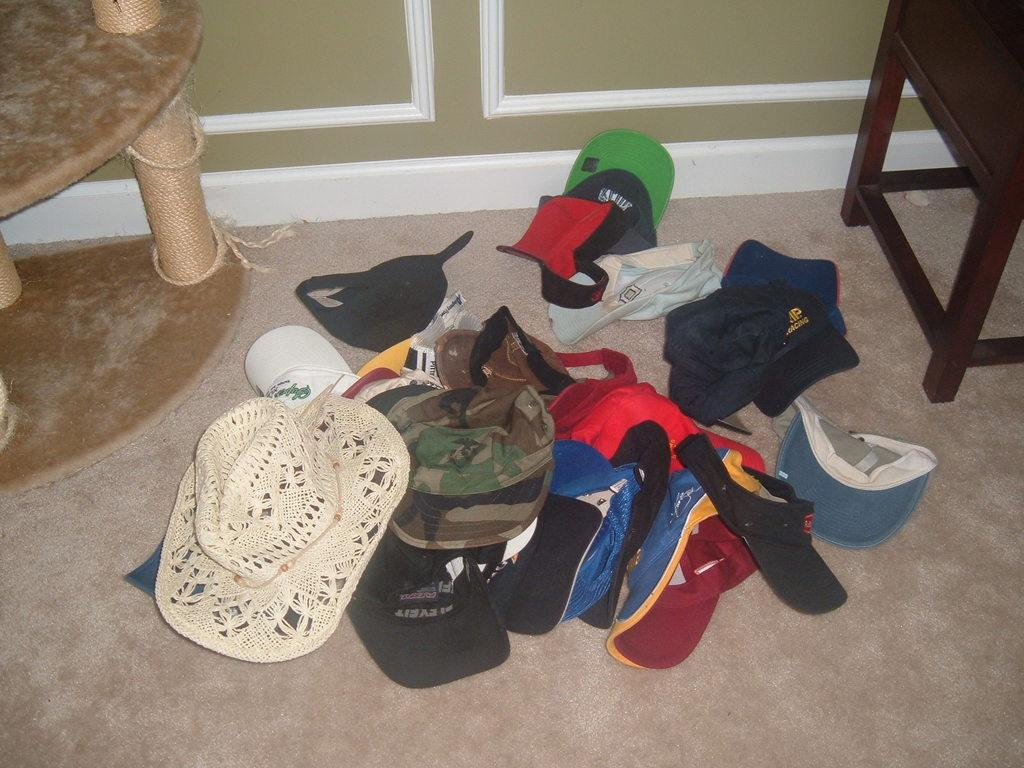What objects are on the path in the image? There are caps and tables on the path in the image. What type of flooring is on the path? There is a carpet on the path in the image. What can be seen in the background of the image? A wall is visible in the background of the image. What time of day is it in the image, and how many eggs are on the tables? The time of day cannot be determined from the image, and there are no eggs present on the tables. 